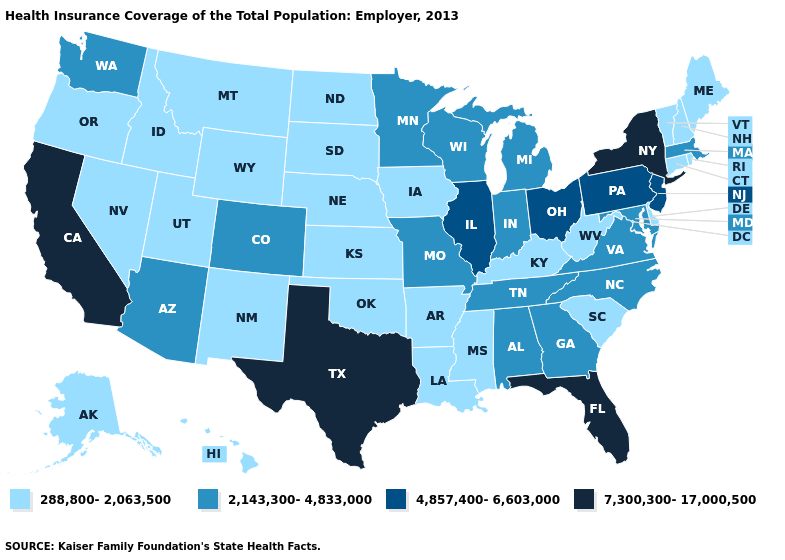Is the legend a continuous bar?
Write a very short answer. No. How many symbols are there in the legend?
Give a very brief answer. 4. What is the value of Colorado?
Concise answer only. 2,143,300-4,833,000. What is the value of Ohio?
Write a very short answer. 4,857,400-6,603,000. Does Pennsylvania have the lowest value in the USA?
Give a very brief answer. No. Among the states that border Idaho , does Wyoming have the lowest value?
Keep it brief. Yes. Does New York have the lowest value in the Northeast?
Quick response, please. No. Name the states that have a value in the range 288,800-2,063,500?
Answer briefly. Alaska, Arkansas, Connecticut, Delaware, Hawaii, Idaho, Iowa, Kansas, Kentucky, Louisiana, Maine, Mississippi, Montana, Nebraska, Nevada, New Hampshire, New Mexico, North Dakota, Oklahoma, Oregon, Rhode Island, South Carolina, South Dakota, Utah, Vermont, West Virginia, Wyoming. Among the states that border Georgia , which have the highest value?
Quick response, please. Florida. What is the lowest value in the West?
Answer briefly. 288,800-2,063,500. Name the states that have a value in the range 7,300,300-17,000,500?
Keep it brief. California, Florida, New York, Texas. Does Maryland have the highest value in the South?
Write a very short answer. No. What is the value of Kentucky?
Write a very short answer. 288,800-2,063,500. 